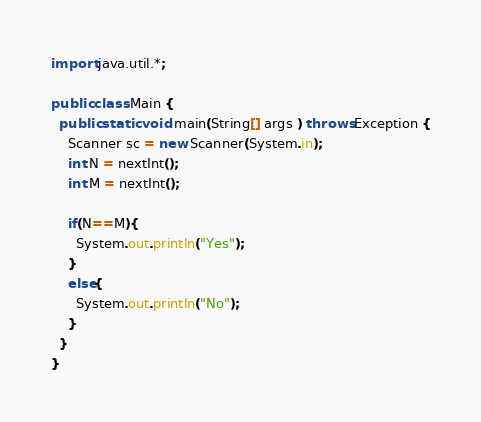Convert code to text. <code><loc_0><loc_0><loc_500><loc_500><_Java_>import java.util.*;

public class Main {
  public static void main(String[] args ) throws Exception {
    Scanner sc = new Scanner(System.in);
    int N = nextInt();
    int M = nextInt();
    
    if(N==M){
      System.out.println("Yes");
    }
    else{
      System.out.println("No");
    }
  }
}</code> 